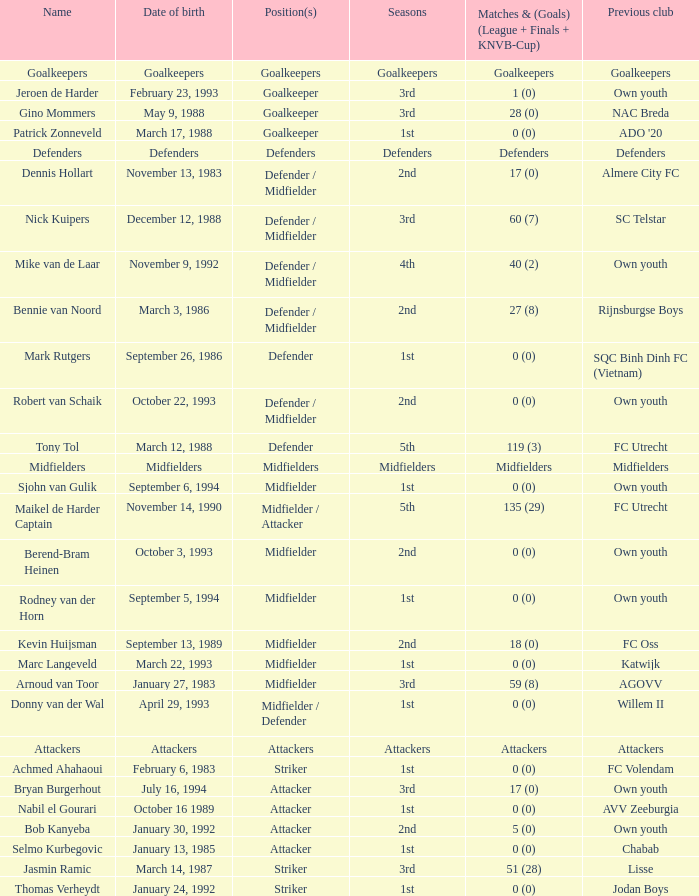Which earlier association was established on october 22, 1993? Own youth. 